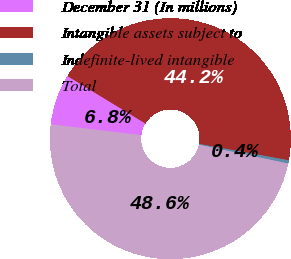Convert chart to OTSL. <chart><loc_0><loc_0><loc_500><loc_500><pie_chart><fcel>December 31 (In millions)<fcel>Intangible assets subject to<fcel>Indefinite-lived intangible<fcel>Total<nl><fcel>6.81%<fcel>44.16%<fcel>0.44%<fcel>48.58%<nl></chart> 